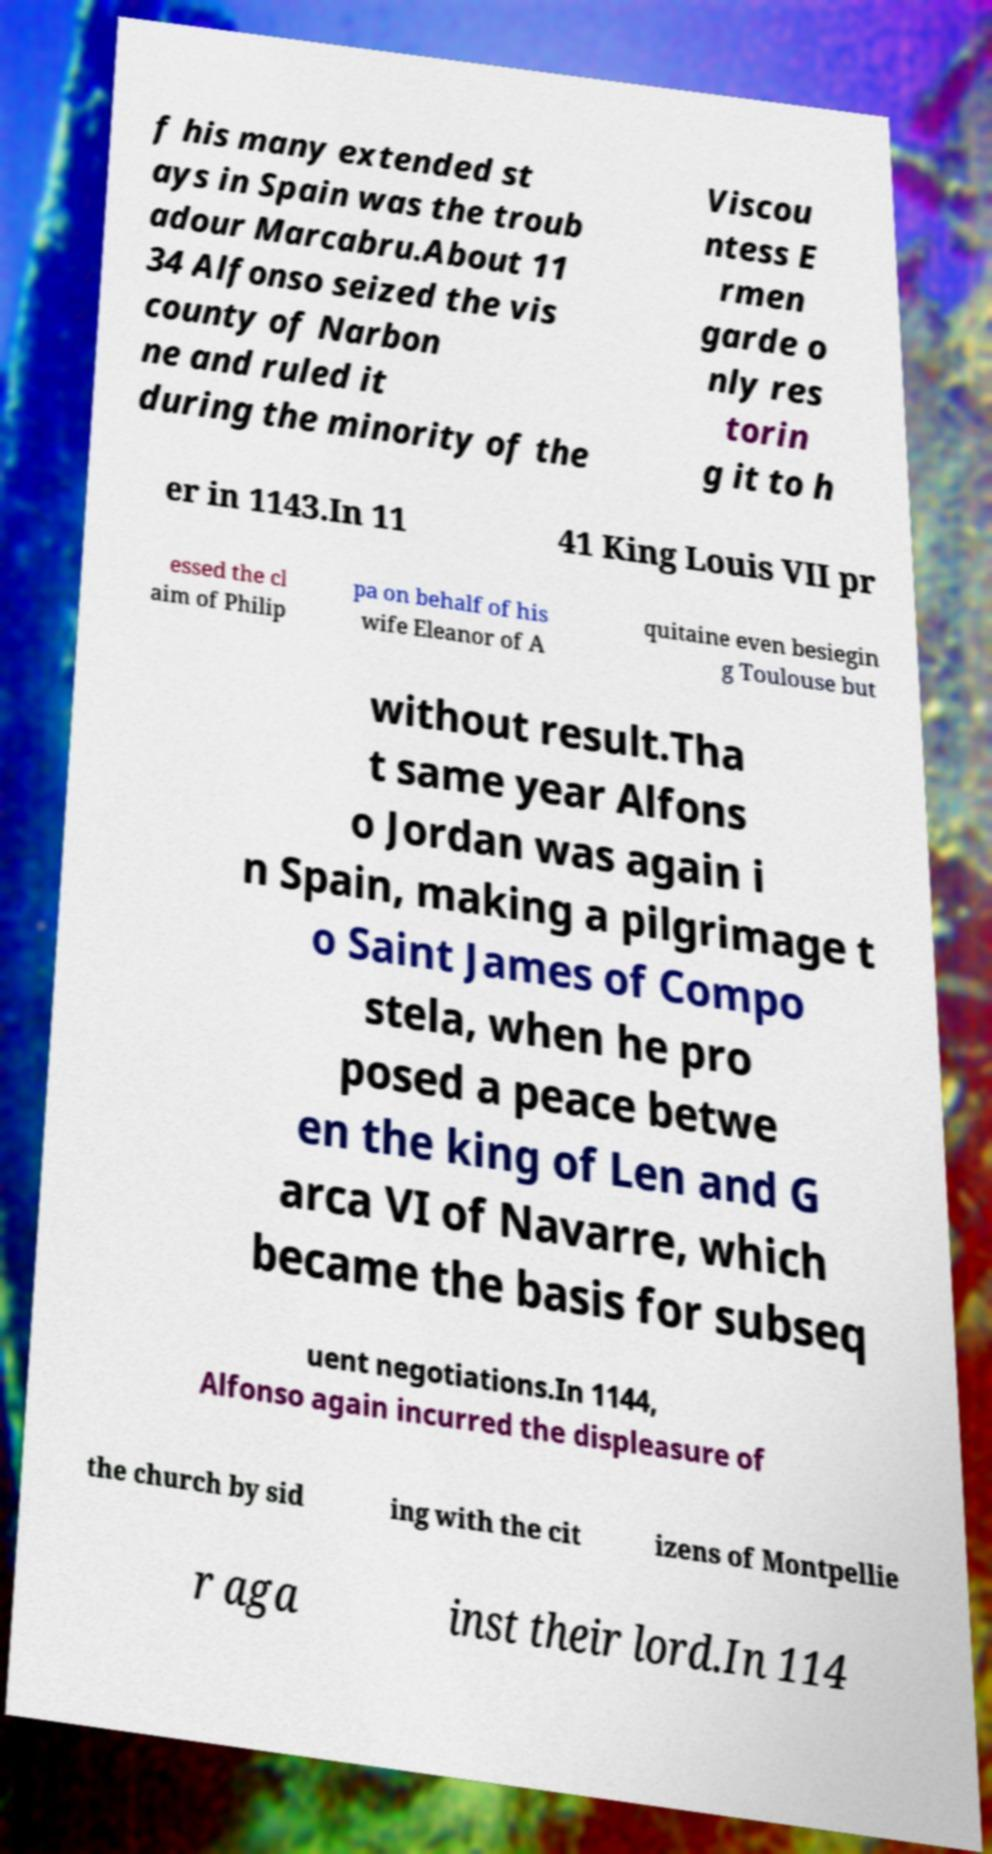There's text embedded in this image that I need extracted. Can you transcribe it verbatim? f his many extended st ays in Spain was the troub adour Marcabru.About 11 34 Alfonso seized the vis county of Narbon ne and ruled it during the minority of the Viscou ntess E rmen garde o nly res torin g it to h er in 1143.In 11 41 King Louis VII pr essed the cl aim of Philip pa on behalf of his wife Eleanor of A quitaine even besiegin g Toulouse but without result.Tha t same year Alfons o Jordan was again i n Spain, making a pilgrimage t o Saint James of Compo stela, when he pro posed a peace betwe en the king of Len and G arca VI of Navarre, which became the basis for subseq uent negotiations.In 1144, Alfonso again incurred the displeasure of the church by sid ing with the cit izens of Montpellie r aga inst their lord.In 114 